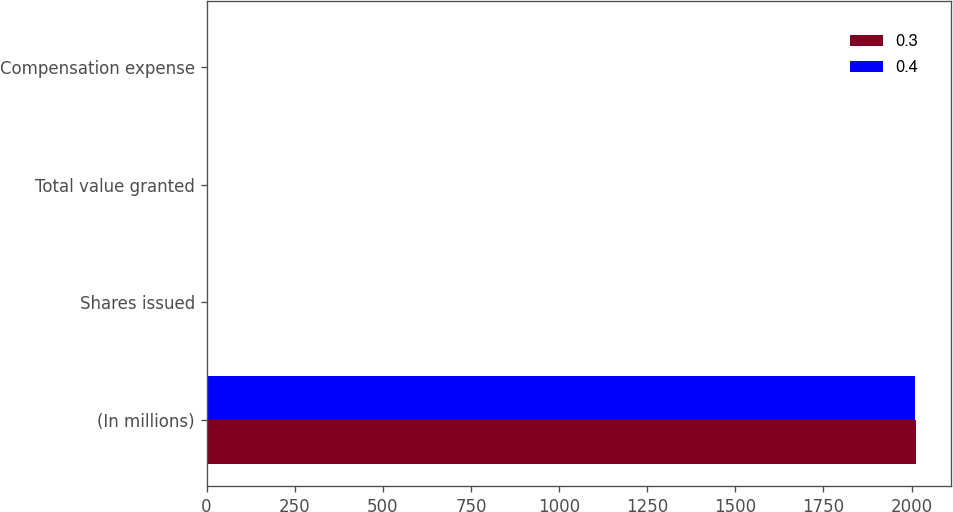<chart> <loc_0><loc_0><loc_500><loc_500><stacked_bar_chart><ecel><fcel>(In millions)<fcel>Shares issued<fcel>Total value granted<fcel>Compensation expense<nl><fcel>0.3<fcel>2011<fcel>0<fcel>0.8<fcel>0.4<nl><fcel>0.4<fcel>2010<fcel>0<fcel>0.3<fcel>0.3<nl></chart> 